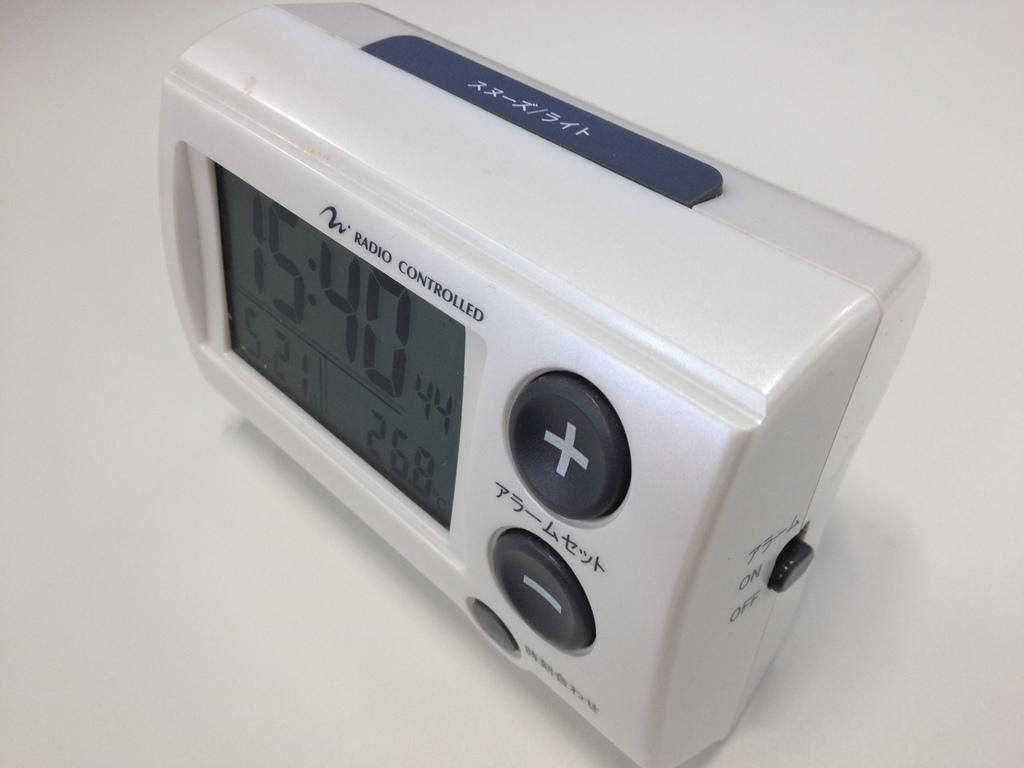<image>
Offer a succinct explanation of the picture presented. White clock with the words RADIO CONTROLLED on the top. 